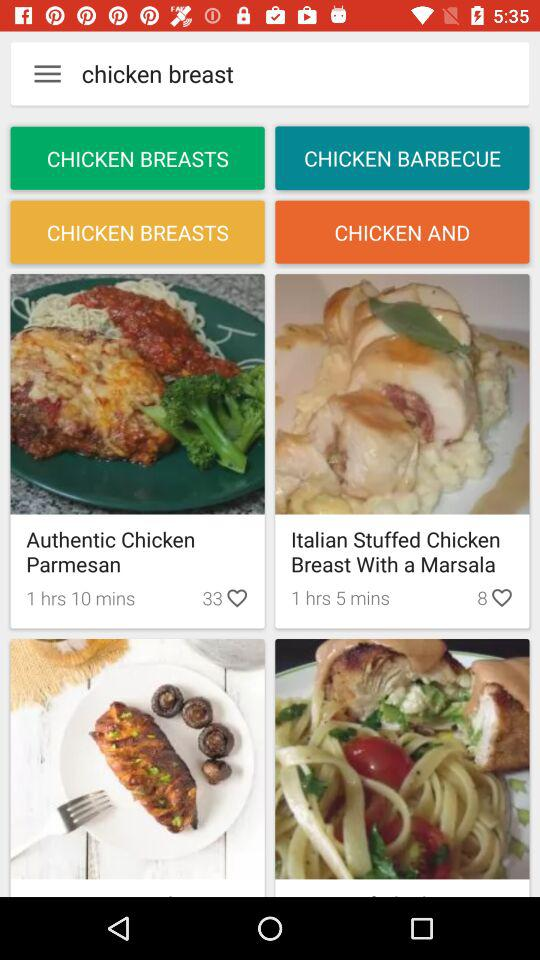Which item has 36 likes on it? The item that has 36 likes on it is "Dark Chocolate Yogurt Cake". 